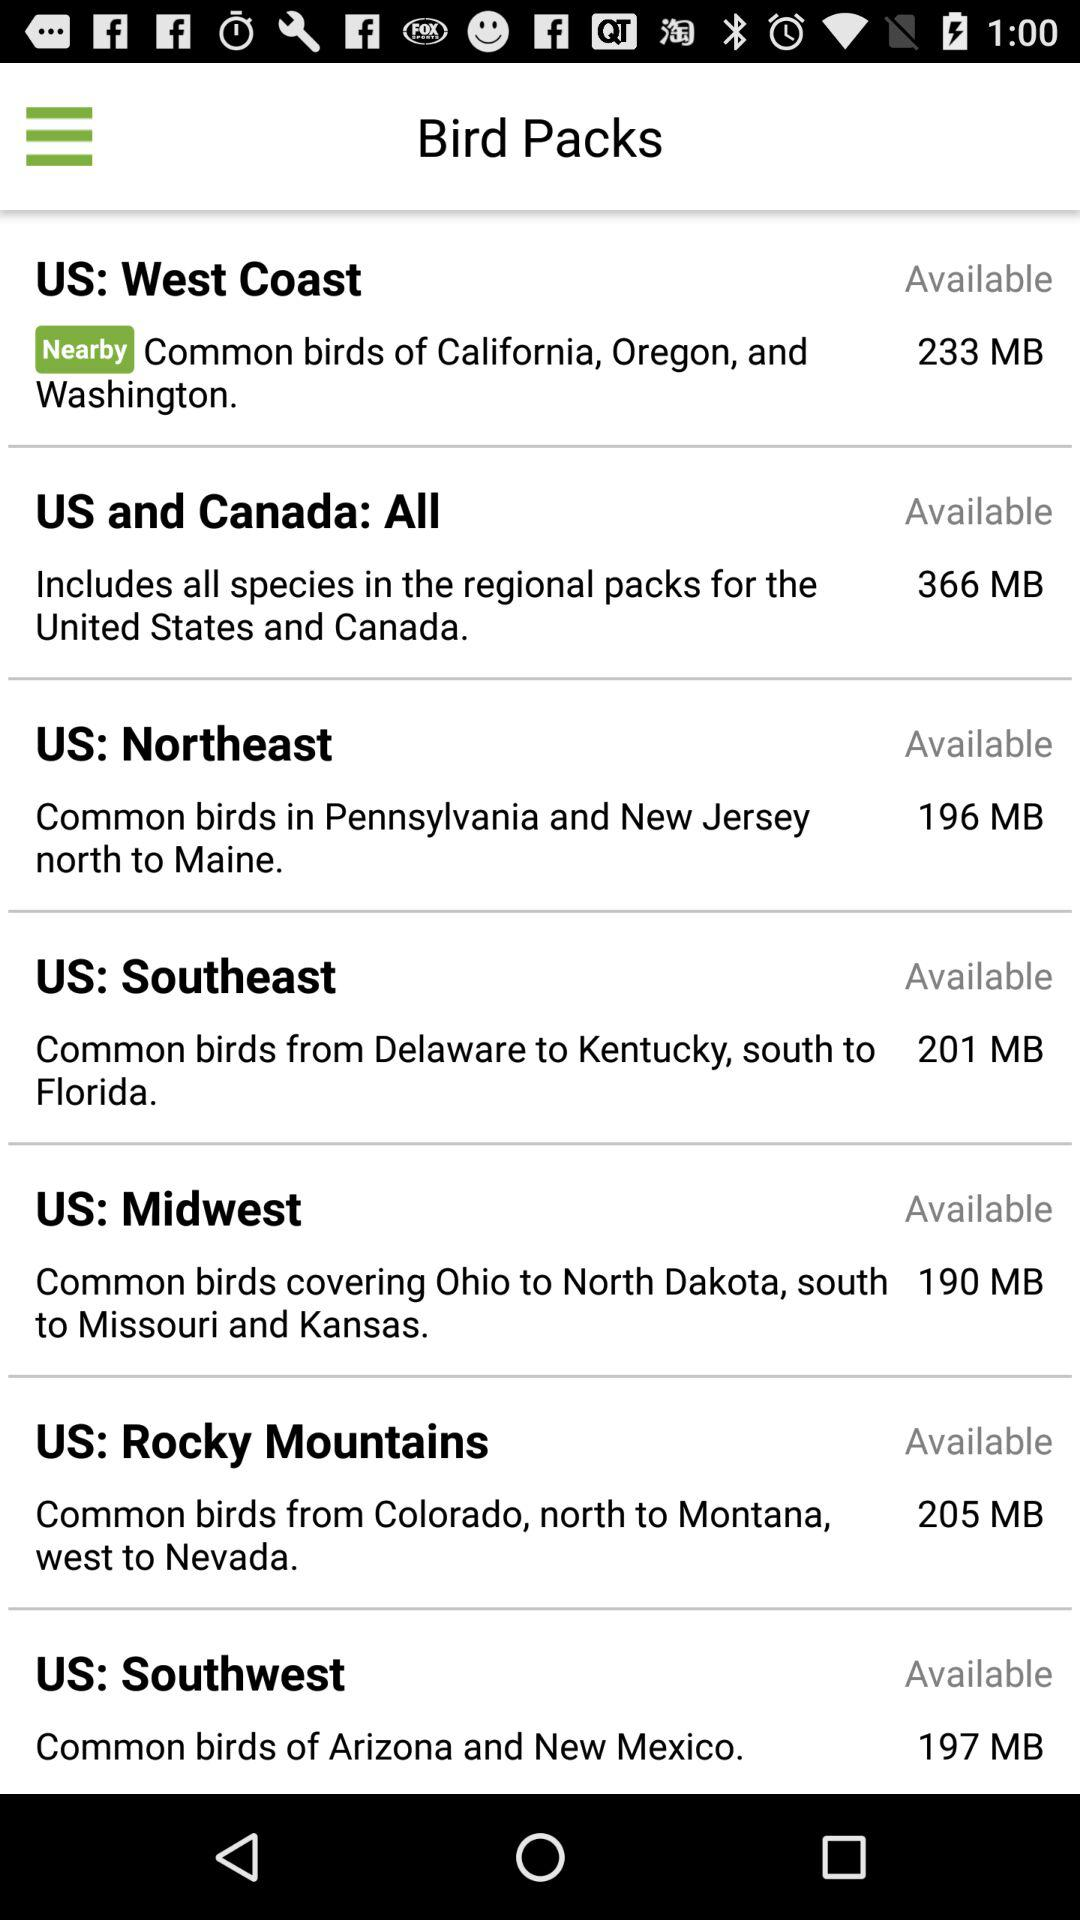Which bird pack is nearby? The nearby bird pack is from the United States: West Coast. 